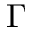<formula> <loc_0><loc_0><loc_500><loc_500>\Gamma</formula> 